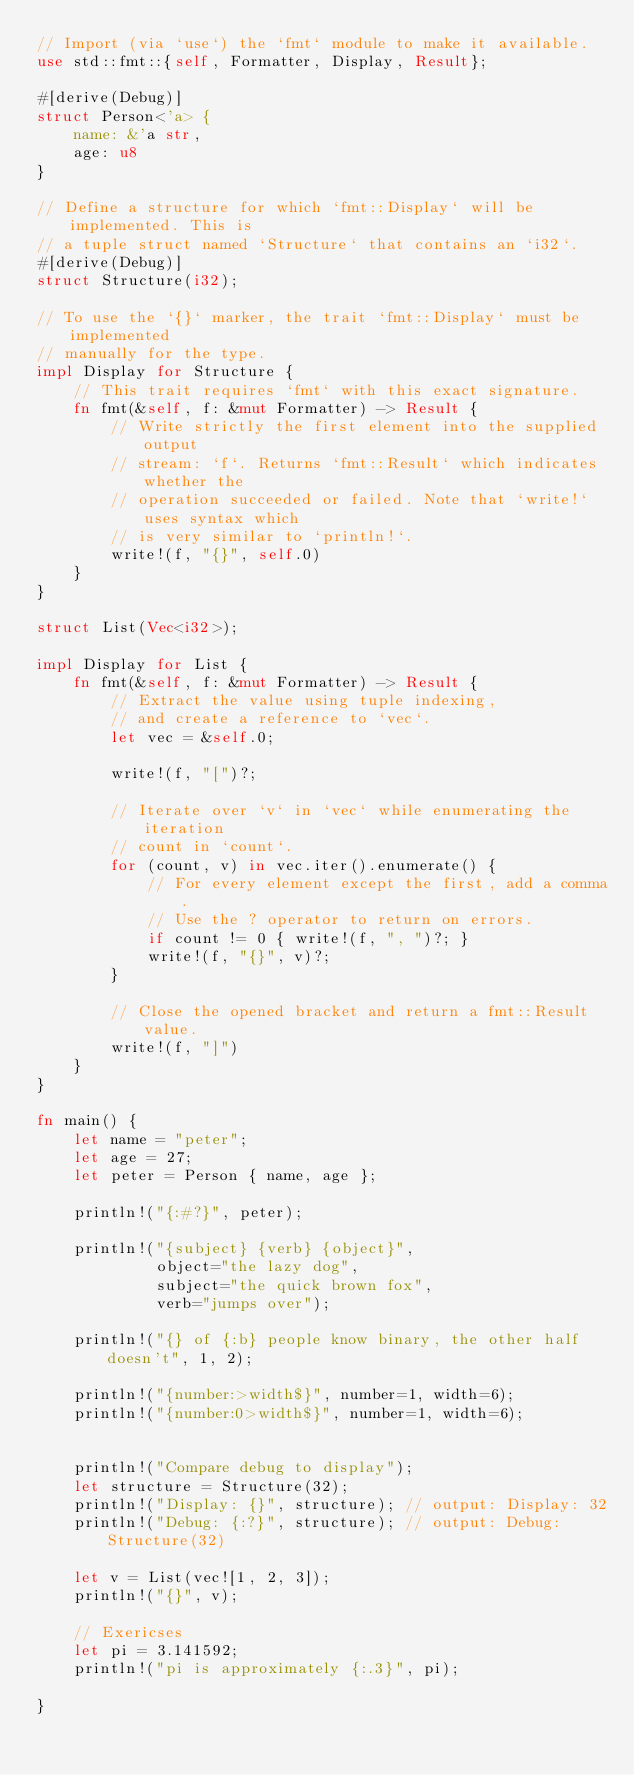<code> <loc_0><loc_0><loc_500><loc_500><_Rust_>// Import (via `use`) the `fmt` module to make it available.
use std::fmt::{self, Formatter, Display, Result};

#[derive(Debug)]
struct Person<'a> {
    name: &'a str,
    age: u8
}

// Define a structure for which `fmt::Display` will be implemented. This is
// a tuple struct named `Structure` that contains an `i32`.
#[derive(Debug)]
struct Structure(i32);

// To use the `{}` marker, the trait `fmt::Display` must be implemented
// manually for the type.
impl Display for Structure {
    // This trait requires `fmt` with this exact signature.
    fn fmt(&self, f: &mut Formatter) -> Result {
        // Write strictly the first element into the supplied output
        // stream: `f`. Returns `fmt::Result` which indicates whether the
        // operation succeeded or failed. Note that `write!` uses syntax which
        // is very similar to `println!`.
        write!(f, "{}", self.0)
    }
}

struct List(Vec<i32>);

impl Display for List {
    fn fmt(&self, f: &mut Formatter) -> Result {
        // Extract the value using tuple indexing,
        // and create a reference to `vec`.
        let vec = &self.0;

        write!(f, "[")?;

        // Iterate over `v` in `vec` while enumerating the iteration
        // count in `count`.
        for (count, v) in vec.iter().enumerate() {
            // For every element except the first, add a comma.
            // Use the ? operator to return on errors.
            if count != 0 { write!(f, ", ")?; }
            write!(f, "{}", v)?;
        }

        // Close the opened bracket and return a fmt::Result value.
        write!(f, "]")
    }
}

fn main() {
    let name = "peter";
    let age = 27;
    let peter = Person { name, age };

    println!("{:#?}", peter);

    println!("{subject} {verb} {object}",
             object="the lazy dog",
             subject="the quick brown fox",
             verb="jumps over");

    println!("{} of {:b} people know binary, the other half doesn't", 1, 2);

    println!("{number:>width$}", number=1, width=6);
    println!("{number:0>width$}", number=1, width=6);


    println!("Compare debug to display");
    let structure = Structure(32);
    println!("Display: {}", structure); // output: Display: 32
    println!("Debug: {:?}", structure); // output: Debug: Structure(32)

    let v = List(vec![1, 2, 3]);
    println!("{}", v);

    // Exericses
    let pi = 3.141592;
    println!("pi is approximately {:.3}", pi);

}
</code> 